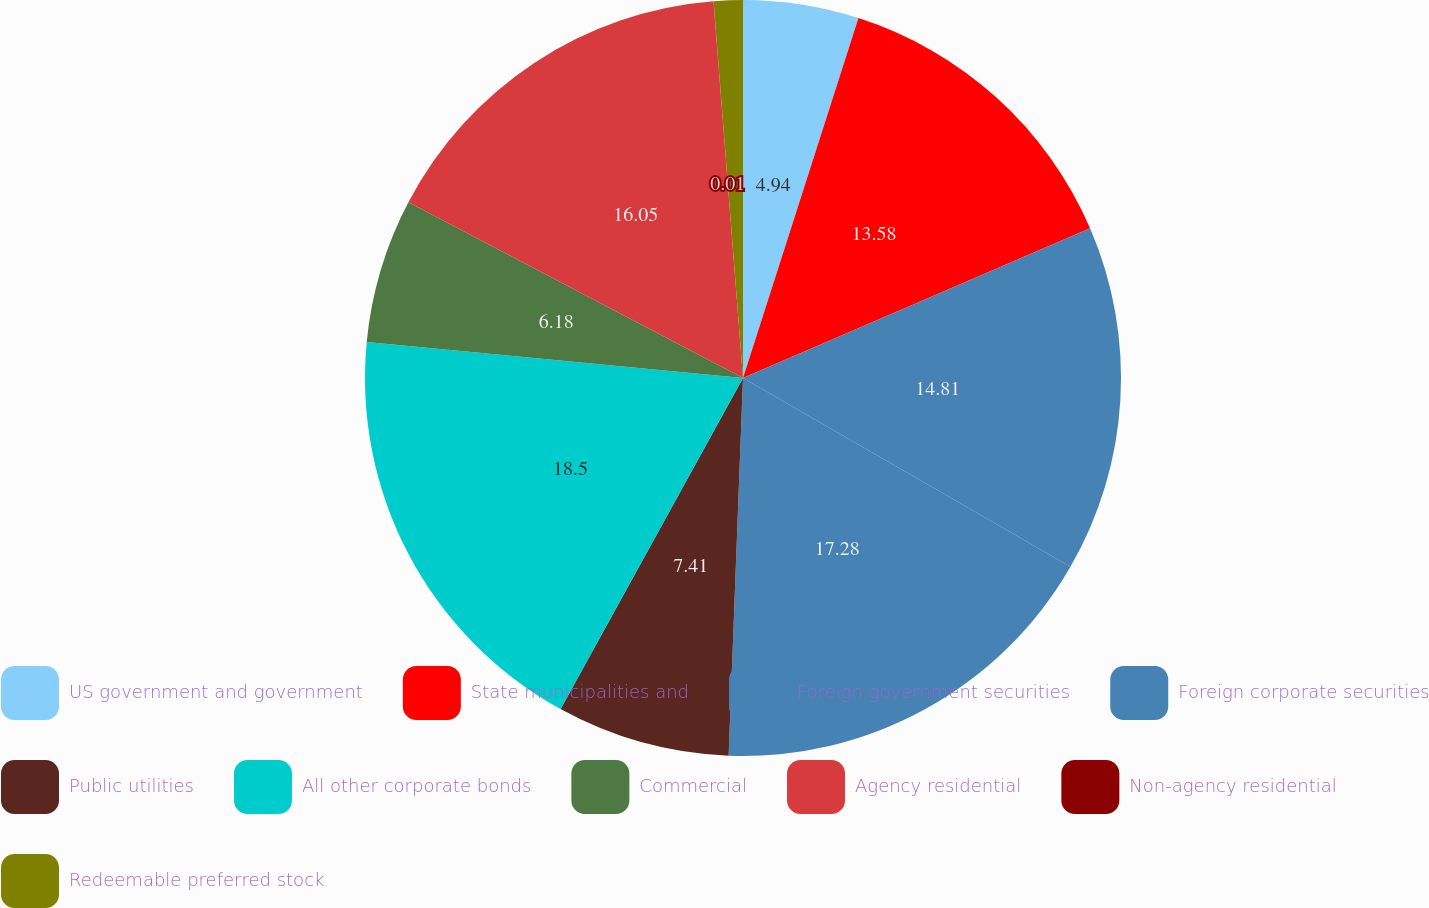Convert chart. <chart><loc_0><loc_0><loc_500><loc_500><pie_chart><fcel>US government and government<fcel>State municipalities and<fcel>Foreign government securities<fcel>Foreign corporate securities<fcel>Public utilities<fcel>All other corporate bonds<fcel>Commercial<fcel>Agency residential<fcel>Non-agency residential<fcel>Redeemable preferred stock<nl><fcel>4.94%<fcel>13.58%<fcel>14.81%<fcel>17.28%<fcel>7.41%<fcel>18.51%<fcel>6.18%<fcel>16.05%<fcel>0.01%<fcel>1.24%<nl></chart> 